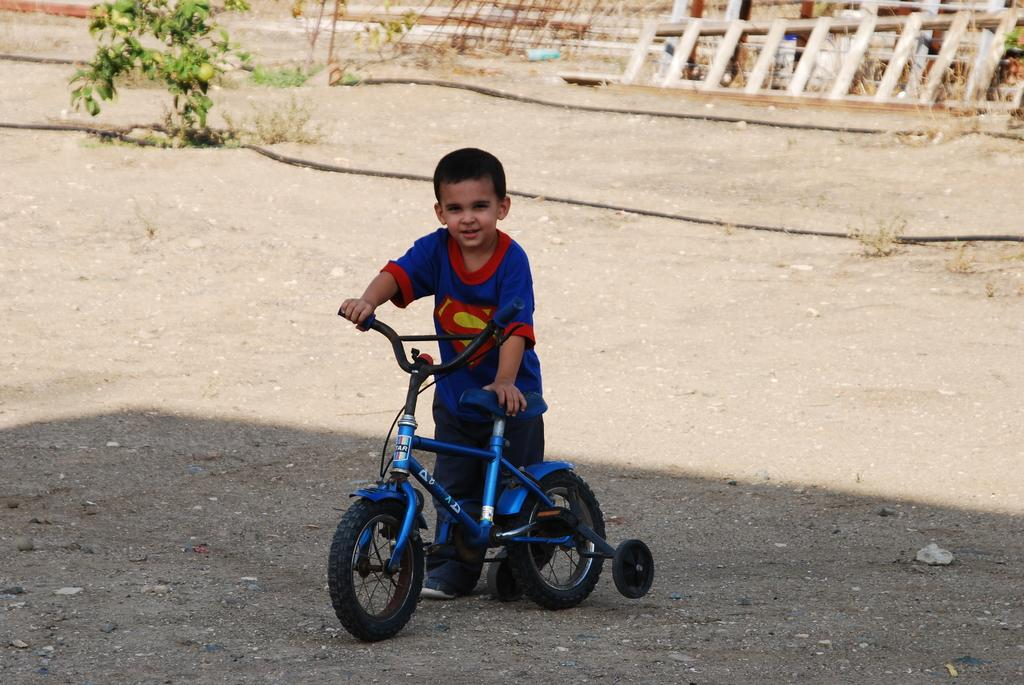Who is the main subject in the image? There is a boy in the image. What is the boy holding in the image? The boy is holding a bicycle. What can be seen in the background of the image? There is a wooden ladder and a small plant in the background of the image. What type of pot is hanging from the bicycle in the image? There is no pot hanging from the bicycle in the image; the boy is simply holding the bicycle. 